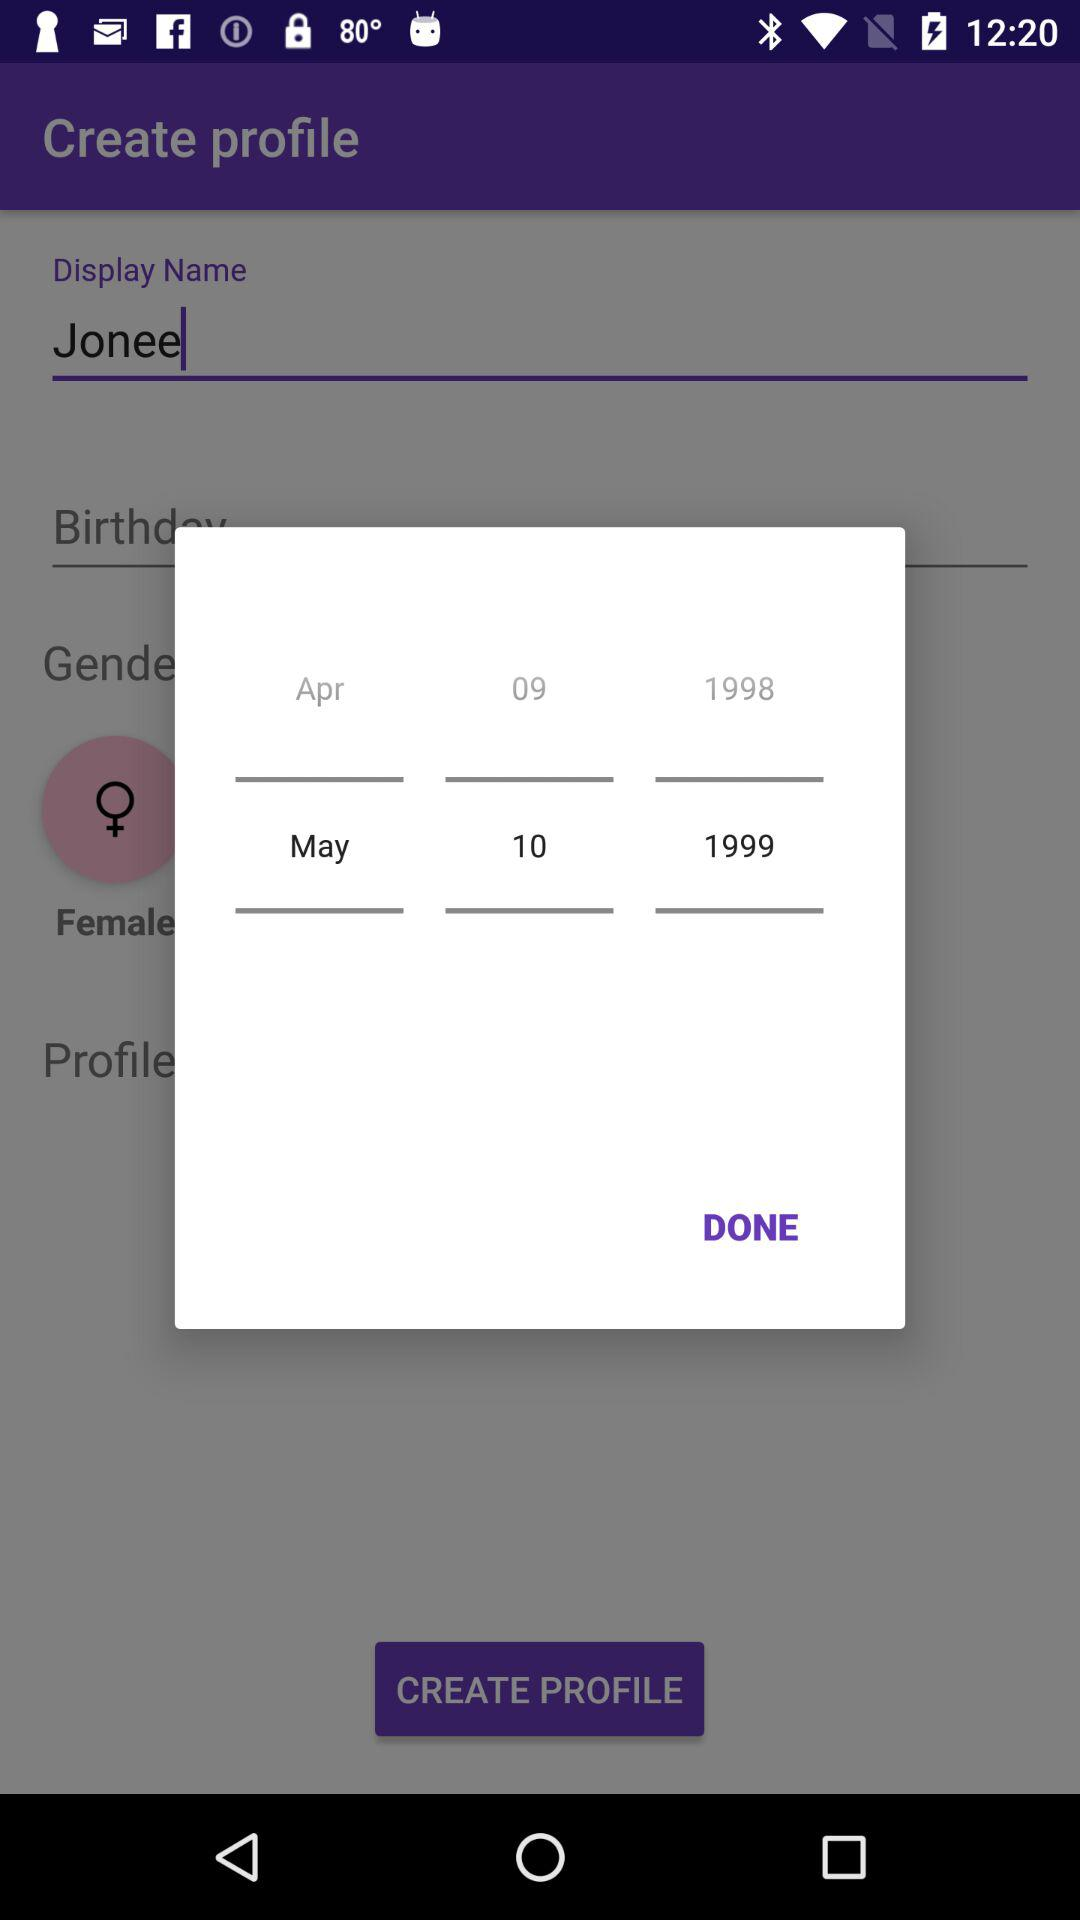What is the selected date? The date is May 10, 1999. 